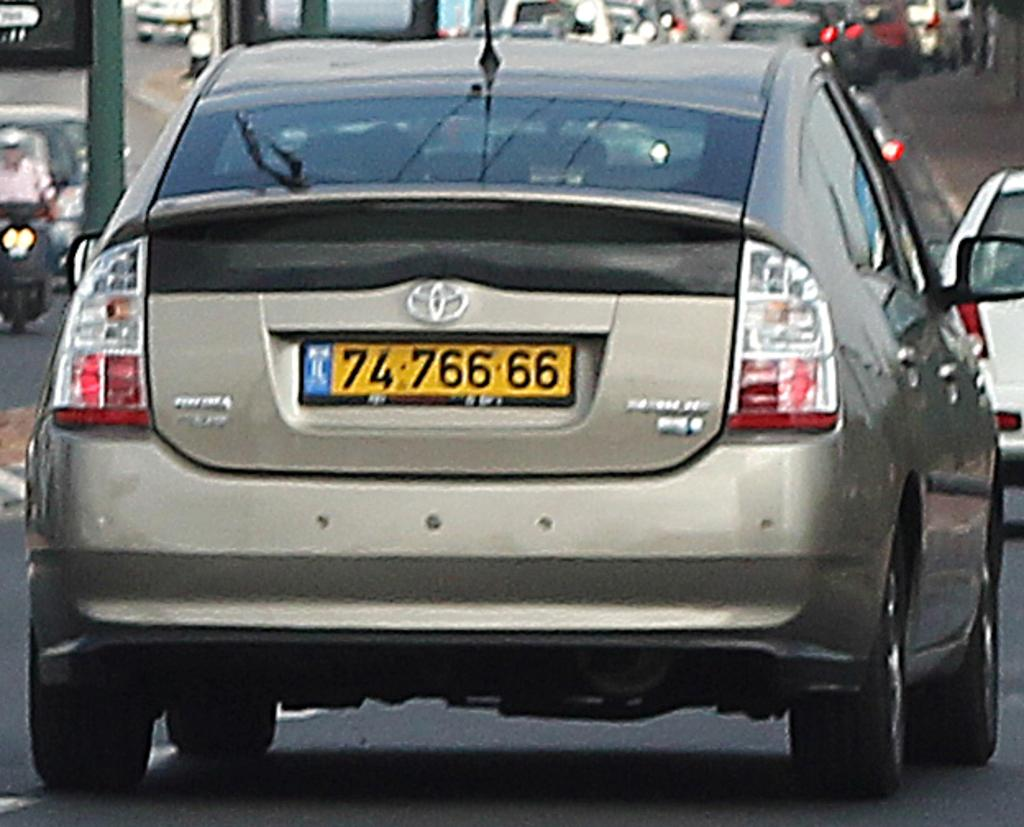<image>
Render a clear and concise summary of the photo. A tan Toyota Prius drives down the road. 